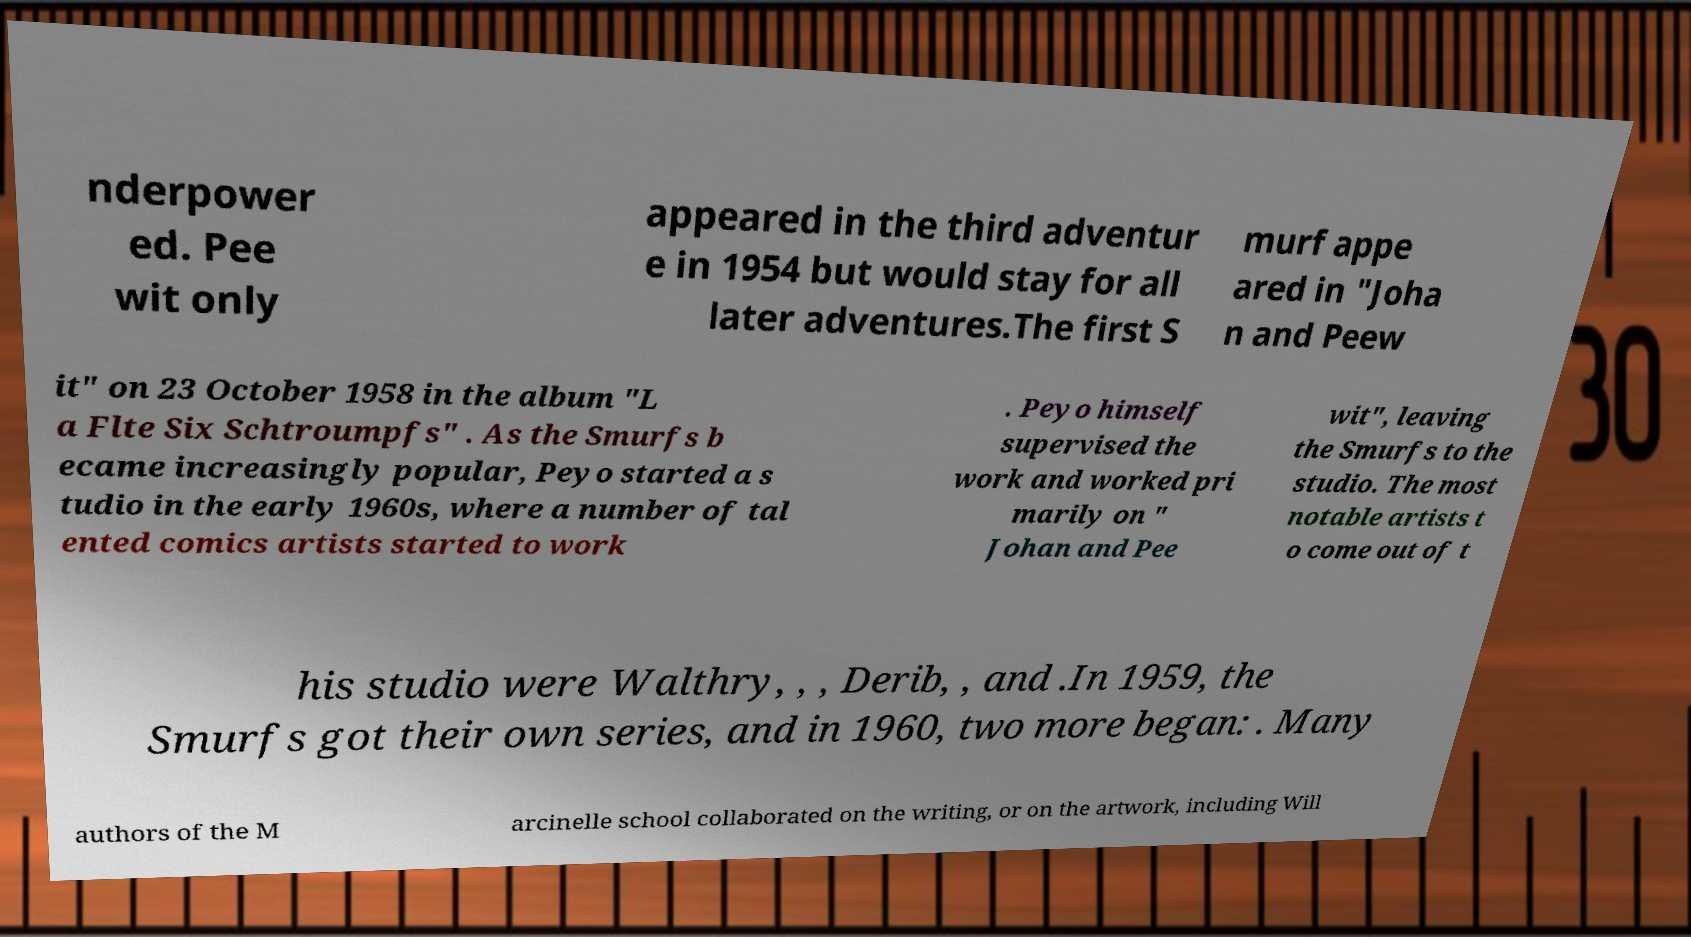Could you assist in decoding the text presented in this image and type it out clearly? nderpower ed. Pee wit only appeared in the third adventur e in 1954 but would stay for all later adventures.The first S murf appe ared in "Joha n and Peew it" on 23 October 1958 in the album "L a Flte Six Schtroumpfs" . As the Smurfs b ecame increasingly popular, Peyo started a s tudio in the early 1960s, where a number of tal ented comics artists started to work . Peyo himself supervised the work and worked pri marily on " Johan and Pee wit", leaving the Smurfs to the studio. The most notable artists t o come out of t his studio were Walthry, , , Derib, , and .In 1959, the Smurfs got their own series, and in 1960, two more began: . Many authors of the M arcinelle school collaborated on the writing, or on the artwork, including Will 